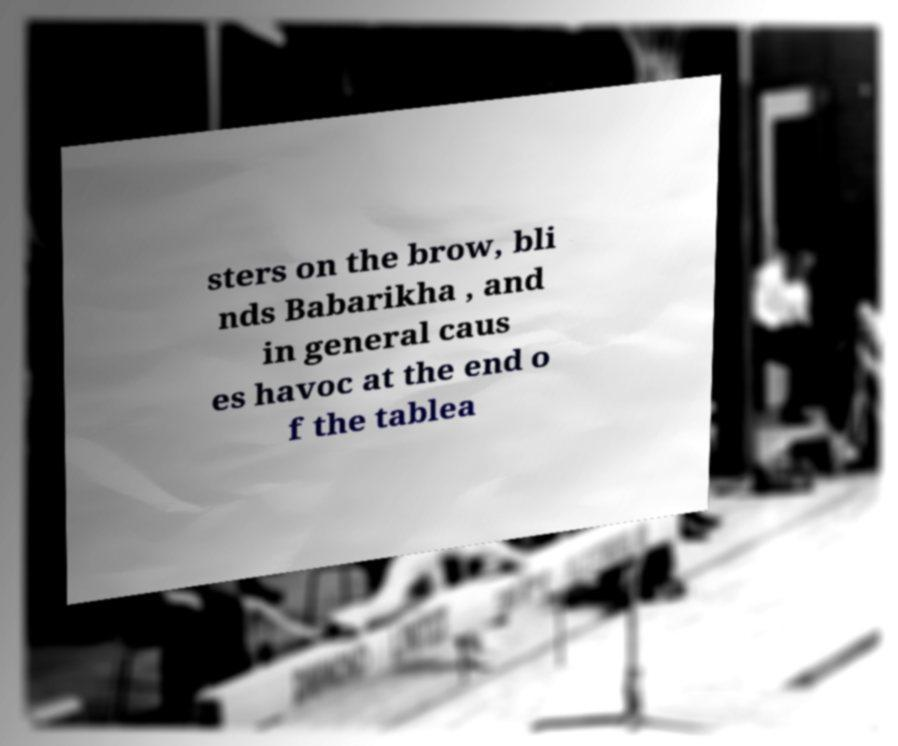What messages or text are displayed in this image? I need them in a readable, typed format. sters on the brow, bli nds Babarikha , and in general caus es havoc at the end o f the tablea 